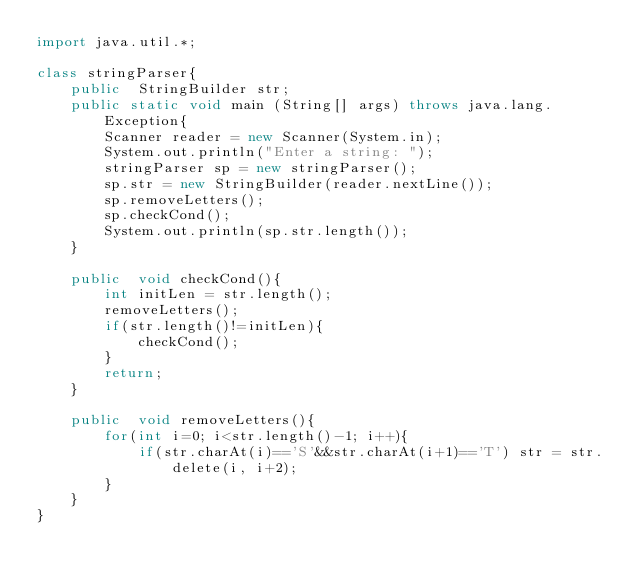<code> <loc_0><loc_0><loc_500><loc_500><_Java_>import java.util.*;

class stringParser{
	public  StringBuilder str;
	public static void main (String[] args) throws java.lang.Exception{
		Scanner reader = new Scanner(System.in);
		System.out.println("Enter a string: ");
		stringParser sp = new stringParser();
		sp.str = new StringBuilder(reader.nextLine());
		sp.removeLetters();
		sp.checkCond();
		System.out.println(sp.str.length());
	}
	
	public  void checkCond(){
		int initLen = str.length();
		removeLetters();
		if(str.length()!=initLen){
			checkCond();
		}
		return;
	}
	
	public  void removeLetters(){
		for(int i=0; i<str.length()-1; i++){
			if(str.charAt(i)=='S'&&str.charAt(i+1)=='T') str = str.delete(i, i+2);
		}
	}
}</code> 